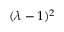<formula> <loc_0><loc_0><loc_500><loc_500>\ ( \lambda - 1 ) ^ { 2 }</formula> 